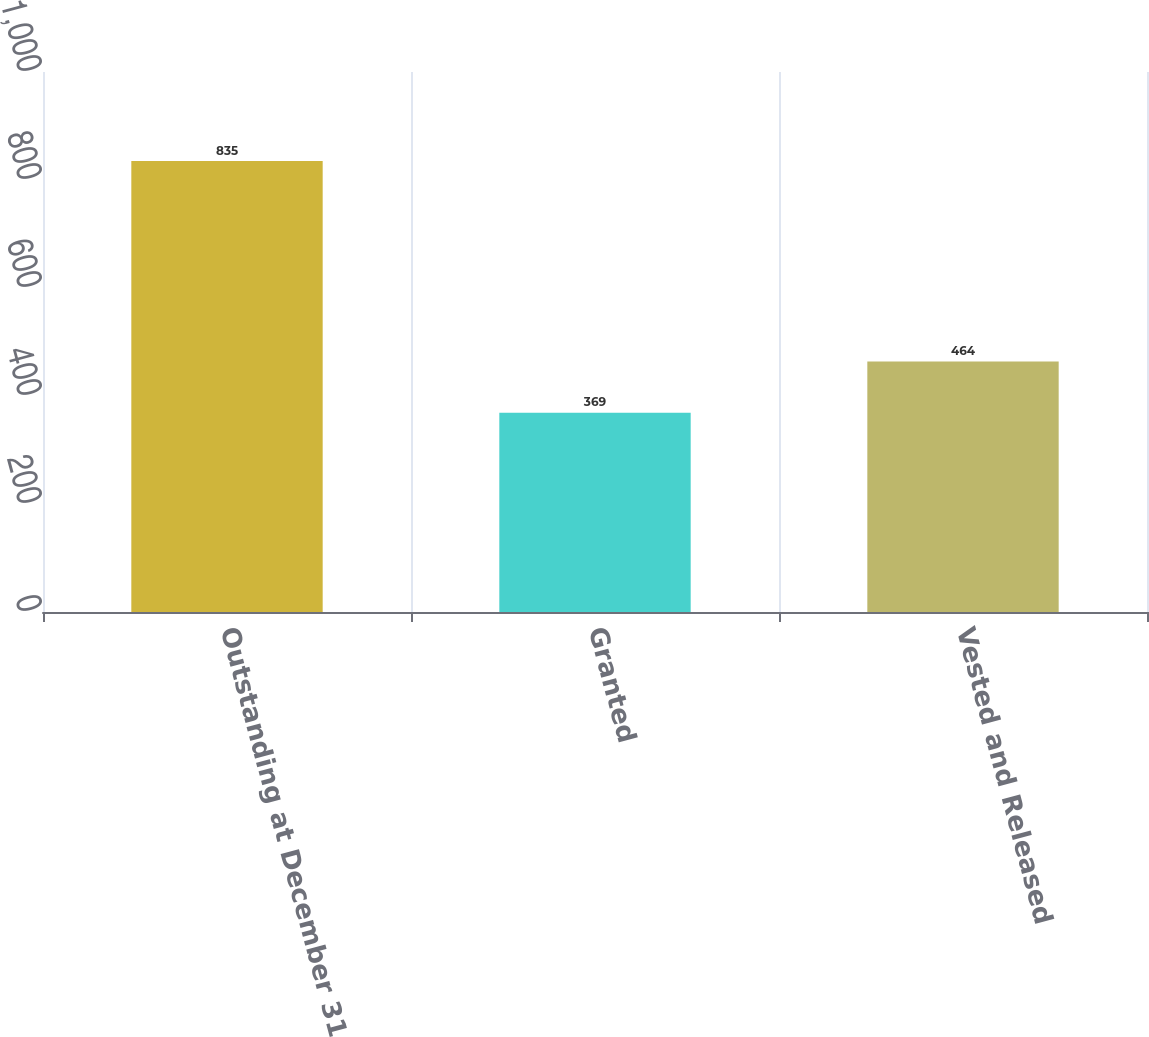<chart> <loc_0><loc_0><loc_500><loc_500><bar_chart><fcel>Outstanding at December 31<fcel>Granted<fcel>Vested and Released<nl><fcel>835<fcel>369<fcel>464<nl></chart> 